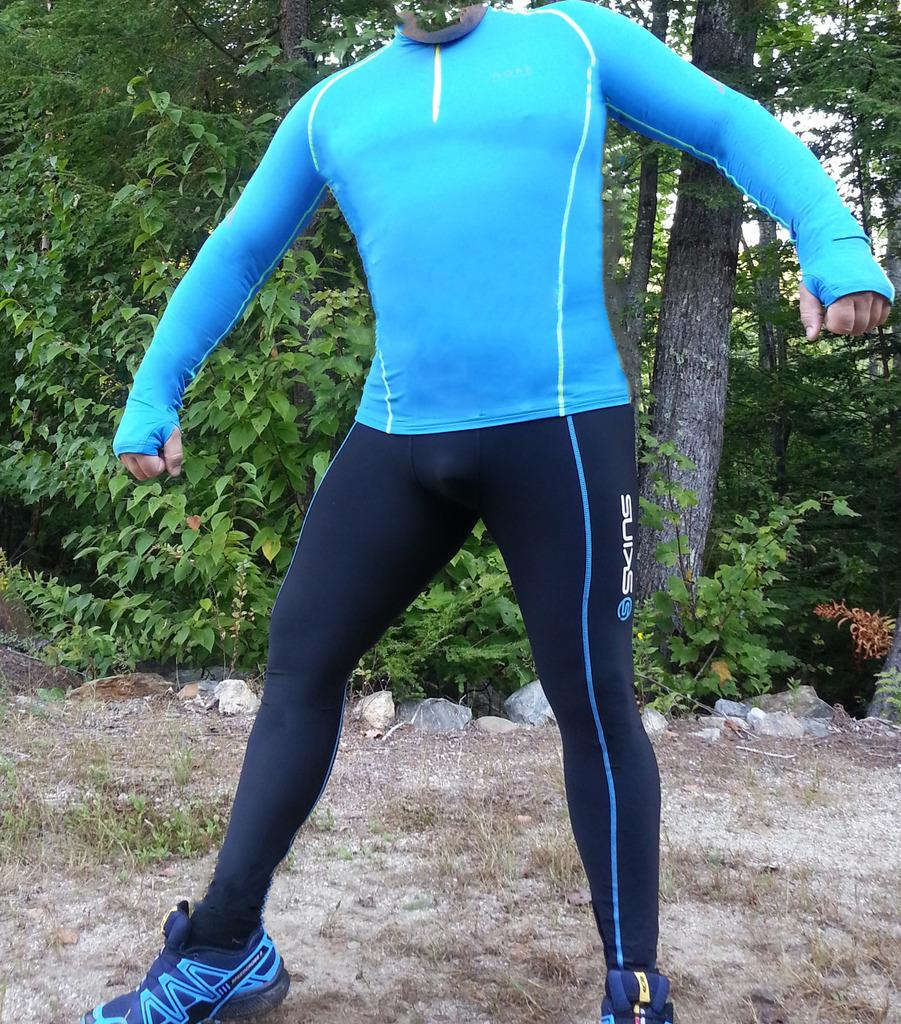What is the main subject of the image? There is a person standing in the center of the image. What can be seen in the background of the image? There are trees in the background of the image. What type of terrain is visible in the image? There are rocks on the ground in the image. Are there any boats visible in the image? No, there are no boats present in the image. 